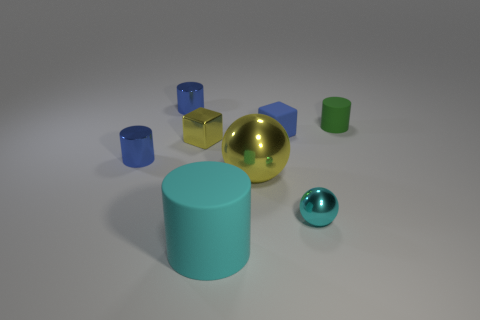Add 1 large rubber things. How many objects exist? 9 Subtract all spheres. How many objects are left? 6 Add 7 cyan metal objects. How many cyan metal objects are left? 8 Add 2 red rubber cylinders. How many red rubber cylinders exist? 2 Subtract 1 blue blocks. How many objects are left? 7 Subtract all large yellow metal spheres. Subtract all shiny spheres. How many objects are left? 5 